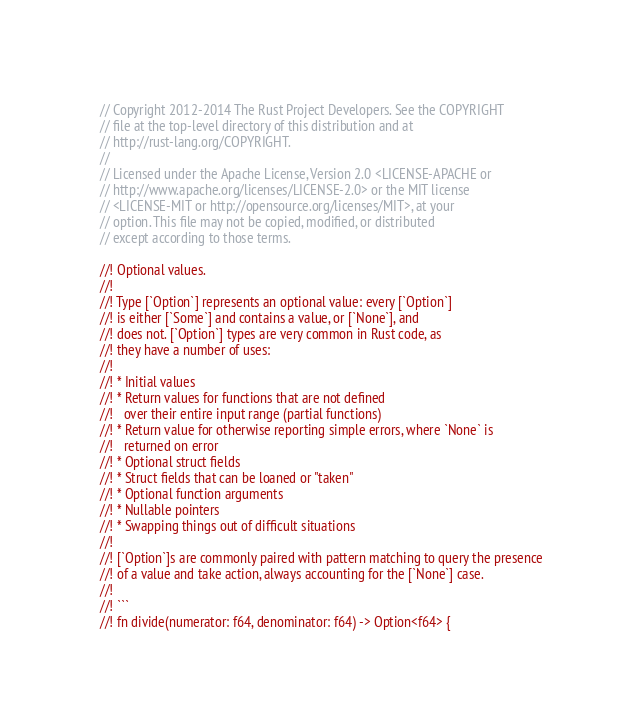Convert code to text. <code><loc_0><loc_0><loc_500><loc_500><_Rust_>// Copyright 2012-2014 The Rust Project Developers. See the COPYRIGHT
// file at the top-level directory of this distribution and at
// http://rust-lang.org/COPYRIGHT.
//
// Licensed under the Apache License, Version 2.0 <LICENSE-APACHE or
// http://www.apache.org/licenses/LICENSE-2.0> or the MIT license
// <LICENSE-MIT or http://opensource.org/licenses/MIT>, at your
// option. This file may not be copied, modified, or distributed
// except according to those terms.

//! Optional values.
//!
//! Type [`Option`] represents an optional value: every [`Option`]
//! is either [`Some`] and contains a value, or [`None`], and
//! does not. [`Option`] types are very common in Rust code, as
//! they have a number of uses:
//!
//! * Initial values
//! * Return values for functions that are not defined
//!   over their entire input range (partial functions)
//! * Return value for otherwise reporting simple errors, where `None` is
//!   returned on error
//! * Optional struct fields
//! * Struct fields that can be loaned or "taken"
//! * Optional function arguments
//! * Nullable pointers
//! * Swapping things out of difficult situations
//!
//! [`Option`]s are commonly paired with pattern matching to query the presence
//! of a value and take action, always accounting for the [`None`] case.
//!
//! ```
//! fn divide(numerator: f64, denominator: f64) -> Option<f64> {</code> 